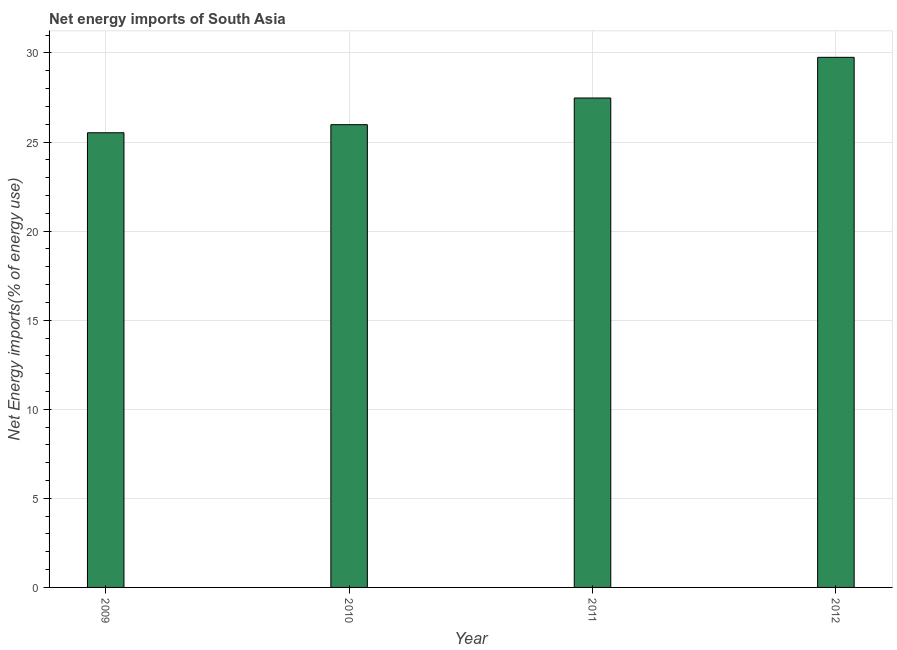Does the graph contain any zero values?
Offer a terse response. No. What is the title of the graph?
Offer a terse response. Net energy imports of South Asia. What is the label or title of the X-axis?
Provide a succinct answer. Year. What is the label or title of the Y-axis?
Offer a very short reply. Net Energy imports(% of energy use). What is the energy imports in 2010?
Offer a terse response. 25.97. Across all years, what is the maximum energy imports?
Make the answer very short. 29.75. Across all years, what is the minimum energy imports?
Give a very brief answer. 25.52. In which year was the energy imports maximum?
Give a very brief answer. 2012. What is the sum of the energy imports?
Keep it short and to the point. 108.72. What is the difference between the energy imports in 2009 and 2012?
Provide a succinct answer. -4.23. What is the average energy imports per year?
Your response must be concise. 27.18. What is the median energy imports?
Keep it short and to the point. 26.72. Do a majority of the years between 2009 and 2012 (inclusive) have energy imports greater than 18 %?
Offer a very short reply. Yes. What is the ratio of the energy imports in 2011 to that in 2012?
Your response must be concise. 0.92. What is the difference between the highest and the second highest energy imports?
Give a very brief answer. 2.28. Is the sum of the energy imports in 2009 and 2012 greater than the maximum energy imports across all years?
Your answer should be compact. Yes. What is the difference between the highest and the lowest energy imports?
Offer a terse response. 4.23. In how many years, is the energy imports greater than the average energy imports taken over all years?
Provide a succinct answer. 2. How many years are there in the graph?
Ensure brevity in your answer.  4. What is the difference between two consecutive major ticks on the Y-axis?
Provide a short and direct response. 5. Are the values on the major ticks of Y-axis written in scientific E-notation?
Make the answer very short. No. What is the Net Energy imports(% of energy use) of 2009?
Give a very brief answer. 25.52. What is the Net Energy imports(% of energy use) of 2010?
Your answer should be very brief. 25.97. What is the Net Energy imports(% of energy use) of 2011?
Your answer should be very brief. 27.47. What is the Net Energy imports(% of energy use) in 2012?
Offer a terse response. 29.75. What is the difference between the Net Energy imports(% of energy use) in 2009 and 2010?
Your answer should be compact. -0.45. What is the difference between the Net Energy imports(% of energy use) in 2009 and 2011?
Your response must be concise. -1.95. What is the difference between the Net Energy imports(% of energy use) in 2009 and 2012?
Keep it short and to the point. -4.23. What is the difference between the Net Energy imports(% of energy use) in 2010 and 2011?
Keep it short and to the point. -1.5. What is the difference between the Net Energy imports(% of energy use) in 2010 and 2012?
Your answer should be compact. -3.78. What is the difference between the Net Energy imports(% of energy use) in 2011 and 2012?
Offer a very short reply. -2.28. What is the ratio of the Net Energy imports(% of energy use) in 2009 to that in 2010?
Keep it short and to the point. 0.98. What is the ratio of the Net Energy imports(% of energy use) in 2009 to that in 2011?
Provide a succinct answer. 0.93. What is the ratio of the Net Energy imports(% of energy use) in 2009 to that in 2012?
Offer a terse response. 0.86. What is the ratio of the Net Energy imports(% of energy use) in 2010 to that in 2011?
Offer a terse response. 0.94. What is the ratio of the Net Energy imports(% of energy use) in 2010 to that in 2012?
Offer a very short reply. 0.87. What is the ratio of the Net Energy imports(% of energy use) in 2011 to that in 2012?
Offer a very short reply. 0.92. 